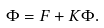Convert formula to latex. <formula><loc_0><loc_0><loc_500><loc_500>\Phi = F + K \Phi .</formula> 